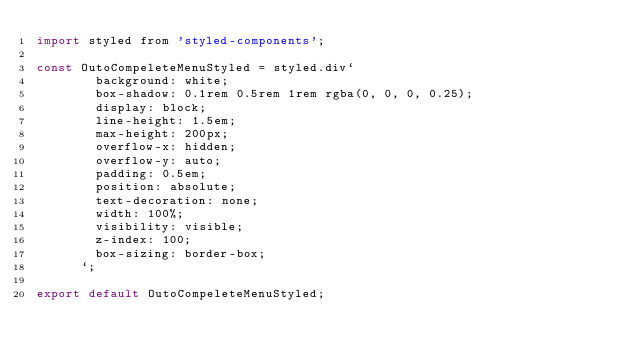Convert code to text. <code><loc_0><loc_0><loc_500><loc_500><_JavaScript_>import styled from 'styled-components';

const OutoCompeleteMenuStyled = styled.div`        
        background: white;
        box-shadow: 0.1rem 0.5rem 1rem rgba(0, 0, 0, 0.25);
        display: block;
        line-height: 1.5em;
        max-height: 200px;
        overflow-x: hidden;
        overflow-y: auto;
        padding: 0.5em;
        position: absolute;
        text-decoration: none;
        width: 100%;
        visibility: visible;
        z-index: 100;
        box-sizing: border-box;
      `;

export default OutoCompeleteMenuStyled;
</code> 